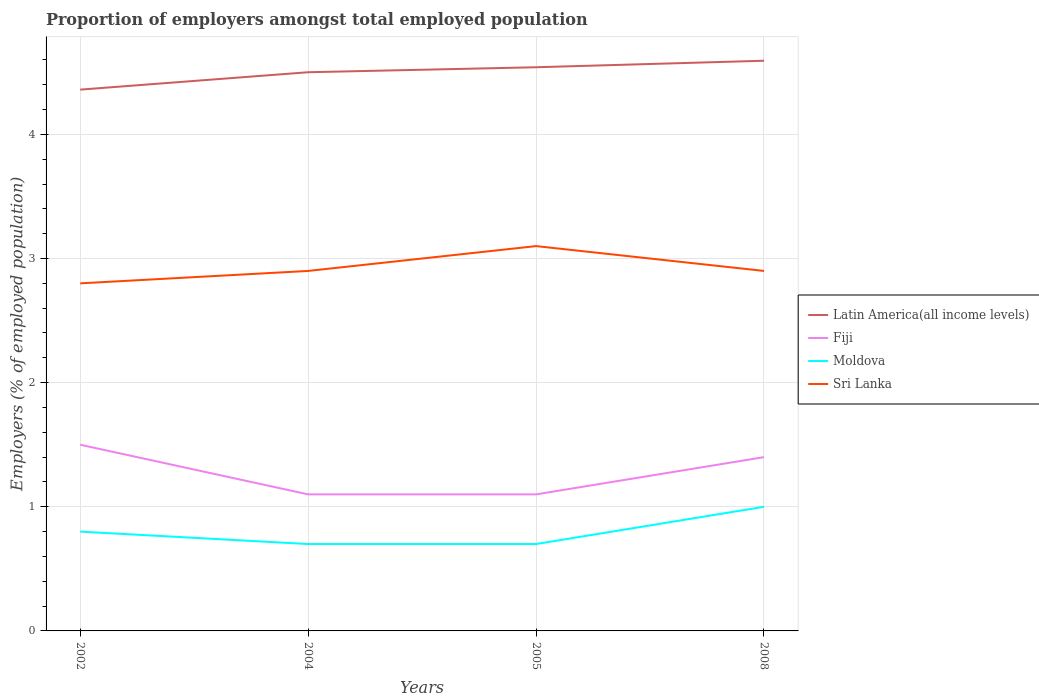How many different coloured lines are there?
Offer a very short reply. 4. Is the number of lines equal to the number of legend labels?
Provide a succinct answer. Yes. Across all years, what is the maximum proportion of employers in Latin America(all income levels)?
Make the answer very short. 4.36. In which year was the proportion of employers in Moldova maximum?
Your answer should be very brief. 2004. What is the total proportion of employers in Sri Lanka in the graph?
Offer a terse response. -0.1. What is the difference between the highest and the second highest proportion of employers in Fiji?
Provide a short and direct response. 0.4. Is the proportion of employers in Fiji strictly greater than the proportion of employers in Sri Lanka over the years?
Provide a short and direct response. Yes. How many lines are there?
Provide a succinct answer. 4. Does the graph contain grids?
Provide a succinct answer. Yes. How are the legend labels stacked?
Your answer should be compact. Vertical. What is the title of the graph?
Your answer should be very brief. Proportion of employers amongst total employed population. What is the label or title of the X-axis?
Your response must be concise. Years. What is the label or title of the Y-axis?
Provide a short and direct response. Employers (% of employed population). What is the Employers (% of employed population) in Latin America(all income levels) in 2002?
Provide a short and direct response. 4.36. What is the Employers (% of employed population) in Moldova in 2002?
Provide a short and direct response. 0.8. What is the Employers (% of employed population) in Sri Lanka in 2002?
Provide a succinct answer. 2.8. What is the Employers (% of employed population) in Latin America(all income levels) in 2004?
Keep it short and to the point. 4.5. What is the Employers (% of employed population) in Fiji in 2004?
Provide a short and direct response. 1.1. What is the Employers (% of employed population) of Moldova in 2004?
Keep it short and to the point. 0.7. What is the Employers (% of employed population) in Sri Lanka in 2004?
Provide a short and direct response. 2.9. What is the Employers (% of employed population) of Latin America(all income levels) in 2005?
Offer a terse response. 4.54. What is the Employers (% of employed population) in Fiji in 2005?
Provide a short and direct response. 1.1. What is the Employers (% of employed population) of Moldova in 2005?
Keep it short and to the point. 0.7. What is the Employers (% of employed population) in Sri Lanka in 2005?
Offer a very short reply. 3.1. What is the Employers (% of employed population) of Latin America(all income levels) in 2008?
Offer a terse response. 4.59. What is the Employers (% of employed population) in Fiji in 2008?
Offer a terse response. 1.4. What is the Employers (% of employed population) of Sri Lanka in 2008?
Give a very brief answer. 2.9. Across all years, what is the maximum Employers (% of employed population) in Latin America(all income levels)?
Keep it short and to the point. 4.59. Across all years, what is the maximum Employers (% of employed population) in Fiji?
Offer a terse response. 1.5. Across all years, what is the maximum Employers (% of employed population) in Moldova?
Give a very brief answer. 1. Across all years, what is the maximum Employers (% of employed population) in Sri Lanka?
Your response must be concise. 3.1. Across all years, what is the minimum Employers (% of employed population) of Latin America(all income levels)?
Provide a short and direct response. 4.36. Across all years, what is the minimum Employers (% of employed population) in Fiji?
Ensure brevity in your answer.  1.1. Across all years, what is the minimum Employers (% of employed population) in Moldova?
Keep it short and to the point. 0.7. Across all years, what is the minimum Employers (% of employed population) in Sri Lanka?
Your answer should be very brief. 2.8. What is the total Employers (% of employed population) of Latin America(all income levels) in the graph?
Offer a very short reply. 18. What is the total Employers (% of employed population) in Moldova in the graph?
Provide a short and direct response. 3.2. What is the total Employers (% of employed population) in Sri Lanka in the graph?
Offer a very short reply. 11.7. What is the difference between the Employers (% of employed population) in Latin America(all income levels) in 2002 and that in 2004?
Your answer should be very brief. -0.14. What is the difference between the Employers (% of employed population) of Fiji in 2002 and that in 2004?
Your answer should be very brief. 0.4. What is the difference between the Employers (% of employed population) in Sri Lanka in 2002 and that in 2004?
Provide a short and direct response. -0.1. What is the difference between the Employers (% of employed population) in Latin America(all income levels) in 2002 and that in 2005?
Keep it short and to the point. -0.18. What is the difference between the Employers (% of employed population) of Fiji in 2002 and that in 2005?
Offer a terse response. 0.4. What is the difference between the Employers (% of employed population) of Sri Lanka in 2002 and that in 2005?
Provide a succinct answer. -0.3. What is the difference between the Employers (% of employed population) of Latin America(all income levels) in 2002 and that in 2008?
Ensure brevity in your answer.  -0.23. What is the difference between the Employers (% of employed population) of Fiji in 2002 and that in 2008?
Your answer should be very brief. 0.1. What is the difference between the Employers (% of employed population) of Moldova in 2002 and that in 2008?
Give a very brief answer. -0.2. What is the difference between the Employers (% of employed population) in Sri Lanka in 2002 and that in 2008?
Make the answer very short. -0.1. What is the difference between the Employers (% of employed population) in Latin America(all income levels) in 2004 and that in 2005?
Offer a terse response. -0.04. What is the difference between the Employers (% of employed population) of Moldova in 2004 and that in 2005?
Ensure brevity in your answer.  0. What is the difference between the Employers (% of employed population) in Latin America(all income levels) in 2004 and that in 2008?
Keep it short and to the point. -0.09. What is the difference between the Employers (% of employed population) of Moldova in 2004 and that in 2008?
Offer a very short reply. -0.3. What is the difference between the Employers (% of employed population) in Latin America(all income levels) in 2005 and that in 2008?
Your response must be concise. -0.05. What is the difference between the Employers (% of employed population) in Fiji in 2005 and that in 2008?
Keep it short and to the point. -0.3. What is the difference between the Employers (% of employed population) in Latin America(all income levels) in 2002 and the Employers (% of employed population) in Fiji in 2004?
Provide a succinct answer. 3.26. What is the difference between the Employers (% of employed population) of Latin America(all income levels) in 2002 and the Employers (% of employed population) of Moldova in 2004?
Provide a short and direct response. 3.66. What is the difference between the Employers (% of employed population) of Latin America(all income levels) in 2002 and the Employers (% of employed population) of Sri Lanka in 2004?
Offer a terse response. 1.46. What is the difference between the Employers (% of employed population) of Fiji in 2002 and the Employers (% of employed population) of Moldova in 2004?
Provide a succinct answer. 0.8. What is the difference between the Employers (% of employed population) in Fiji in 2002 and the Employers (% of employed population) in Sri Lanka in 2004?
Keep it short and to the point. -1.4. What is the difference between the Employers (% of employed population) in Moldova in 2002 and the Employers (% of employed population) in Sri Lanka in 2004?
Ensure brevity in your answer.  -2.1. What is the difference between the Employers (% of employed population) of Latin America(all income levels) in 2002 and the Employers (% of employed population) of Fiji in 2005?
Ensure brevity in your answer.  3.26. What is the difference between the Employers (% of employed population) in Latin America(all income levels) in 2002 and the Employers (% of employed population) in Moldova in 2005?
Your answer should be compact. 3.66. What is the difference between the Employers (% of employed population) in Latin America(all income levels) in 2002 and the Employers (% of employed population) in Sri Lanka in 2005?
Give a very brief answer. 1.26. What is the difference between the Employers (% of employed population) of Fiji in 2002 and the Employers (% of employed population) of Moldova in 2005?
Make the answer very short. 0.8. What is the difference between the Employers (% of employed population) of Fiji in 2002 and the Employers (% of employed population) of Sri Lanka in 2005?
Provide a succinct answer. -1.6. What is the difference between the Employers (% of employed population) in Moldova in 2002 and the Employers (% of employed population) in Sri Lanka in 2005?
Give a very brief answer. -2.3. What is the difference between the Employers (% of employed population) in Latin America(all income levels) in 2002 and the Employers (% of employed population) in Fiji in 2008?
Offer a terse response. 2.96. What is the difference between the Employers (% of employed population) of Latin America(all income levels) in 2002 and the Employers (% of employed population) of Moldova in 2008?
Make the answer very short. 3.36. What is the difference between the Employers (% of employed population) of Latin America(all income levels) in 2002 and the Employers (% of employed population) of Sri Lanka in 2008?
Give a very brief answer. 1.46. What is the difference between the Employers (% of employed population) of Fiji in 2002 and the Employers (% of employed population) of Sri Lanka in 2008?
Keep it short and to the point. -1.4. What is the difference between the Employers (% of employed population) of Moldova in 2002 and the Employers (% of employed population) of Sri Lanka in 2008?
Provide a short and direct response. -2.1. What is the difference between the Employers (% of employed population) of Latin America(all income levels) in 2004 and the Employers (% of employed population) of Fiji in 2005?
Your answer should be very brief. 3.4. What is the difference between the Employers (% of employed population) in Latin America(all income levels) in 2004 and the Employers (% of employed population) in Moldova in 2005?
Your answer should be compact. 3.8. What is the difference between the Employers (% of employed population) in Latin America(all income levels) in 2004 and the Employers (% of employed population) in Sri Lanka in 2005?
Your answer should be very brief. 1.4. What is the difference between the Employers (% of employed population) in Fiji in 2004 and the Employers (% of employed population) in Sri Lanka in 2005?
Your answer should be very brief. -2. What is the difference between the Employers (% of employed population) of Latin America(all income levels) in 2004 and the Employers (% of employed population) of Fiji in 2008?
Ensure brevity in your answer.  3.1. What is the difference between the Employers (% of employed population) in Latin America(all income levels) in 2004 and the Employers (% of employed population) in Moldova in 2008?
Offer a very short reply. 3.5. What is the difference between the Employers (% of employed population) in Latin America(all income levels) in 2004 and the Employers (% of employed population) in Sri Lanka in 2008?
Ensure brevity in your answer.  1.6. What is the difference between the Employers (% of employed population) of Fiji in 2004 and the Employers (% of employed population) of Sri Lanka in 2008?
Give a very brief answer. -1.8. What is the difference between the Employers (% of employed population) of Moldova in 2004 and the Employers (% of employed population) of Sri Lanka in 2008?
Your response must be concise. -2.2. What is the difference between the Employers (% of employed population) of Latin America(all income levels) in 2005 and the Employers (% of employed population) of Fiji in 2008?
Offer a terse response. 3.14. What is the difference between the Employers (% of employed population) in Latin America(all income levels) in 2005 and the Employers (% of employed population) in Moldova in 2008?
Offer a terse response. 3.54. What is the difference between the Employers (% of employed population) of Latin America(all income levels) in 2005 and the Employers (% of employed population) of Sri Lanka in 2008?
Offer a very short reply. 1.64. What is the difference between the Employers (% of employed population) of Fiji in 2005 and the Employers (% of employed population) of Moldova in 2008?
Make the answer very short. 0.1. What is the difference between the Employers (% of employed population) in Fiji in 2005 and the Employers (% of employed population) in Sri Lanka in 2008?
Keep it short and to the point. -1.8. What is the difference between the Employers (% of employed population) in Moldova in 2005 and the Employers (% of employed population) in Sri Lanka in 2008?
Your answer should be compact. -2.2. What is the average Employers (% of employed population) in Latin America(all income levels) per year?
Keep it short and to the point. 4.5. What is the average Employers (% of employed population) in Fiji per year?
Make the answer very short. 1.27. What is the average Employers (% of employed population) of Sri Lanka per year?
Provide a short and direct response. 2.92. In the year 2002, what is the difference between the Employers (% of employed population) in Latin America(all income levels) and Employers (% of employed population) in Fiji?
Your response must be concise. 2.86. In the year 2002, what is the difference between the Employers (% of employed population) of Latin America(all income levels) and Employers (% of employed population) of Moldova?
Keep it short and to the point. 3.56. In the year 2002, what is the difference between the Employers (% of employed population) in Latin America(all income levels) and Employers (% of employed population) in Sri Lanka?
Offer a terse response. 1.56. In the year 2002, what is the difference between the Employers (% of employed population) of Fiji and Employers (% of employed population) of Moldova?
Provide a short and direct response. 0.7. In the year 2002, what is the difference between the Employers (% of employed population) in Fiji and Employers (% of employed population) in Sri Lanka?
Provide a short and direct response. -1.3. In the year 2002, what is the difference between the Employers (% of employed population) of Moldova and Employers (% of employed population) of Sri Lanka?
Keep it short and to the point. -2. In the year 2004, what is the difference between the Employers (% of employed population) in Latin America(all income levels) and Employers (% of employed population) in Fiji?
Your answer should be compact. 3.4. In the year 2004, what is the difference between the Employers (% of employed population) in Latin America(all income levels) and Employers (% of employed population) in Moldova?
Ensure brevity in your answer.  3.8. In the year 2004, what is the difference between the Employers (% of employed population) in Latin America(all income levels) and Employers (% of employed population) in Sri Lanka?
Make the answer very short. 1.6. In the year 2004, what is the difference between the Employers (% of employed population) in Fiji and Employers (% of employed population) in Moldova?
Your response must be concise. 0.4. In the year 2004, what is the difference between the Employers (% of employed population) of Moldova and Employers (% of employed population) of Sri Lanka?
Provide a short and direct response. -2.2. In the year 2005, what is the difference between the Employers (% of employed population) of Latin America(all income levels) and Employers (% of employed population) of Fiji?
Keep it short and to the point. 3.44. In the year 2005, what is the difference between the Employers (% of employed population) of Latin America(all income levels) and Employers (% of employed population) of Moldova?
Your answer should be compact. 3.84. In the year 2005, what is the difference between the Employers (% of employed population) of Latin America(all income levels) and Employers (% of employed population) of Sri Lanka?
Your answer should be very brief. 1.44. In the year 2005, what is the difference between the Employers (% of employed population) of Fiji and Employers (% of employed population) of Moldova?
Keep it short and to the point. 0.4. In the year 2005, what is the difference between the Employers (% of employed population) in Fiji and Employers (% of employed population) in Sri Lanka?
Make the answer very short. -2. In the year 2005, what is the difference between the Employers (% of employed population) of Moldova and Employers (% of employed population) of Sri Lanka?
Ensure brevity in your answer.  -2.4. In the year 2008, what is the difference between the Employers (% of employed population) of Latin America(all income levels) and Employers (% of employed population) of Fiji?
Offer a terse response. 3.19. In the year 2008, what is the difference between the Employers (% of employed population) in Latin America(all income levels) and Employers (% of employed population) in Moldova?
Your answer should be compact. 3.59. In the year 2008, what is the difference between the Employers (% of employed population) of Latin America(all income levels) and Employers (% of employed population) of Sri Lanka?
Your response must be concise. 1.69. In the year 2008, what is the difference between the Employers (% of employed population) of Moldova and Employers (% of employed population) of Sri Lanka?
Your answer should be compact. -1.9. What is the ratio of the Employers (% of employed population) of Latin America(all income levels) in 2002 to that in 2004?
Your answer should be compact. 0.97. What is the ratio of the Employers (% of employed population) in Fiji in 2002 to that in 2004?
Ensure brevity in your answer.  1.36. What is the ratio of the Employers (% of employed population) of Sri Lanka in 2002 to that in 2004?
Give a very brief answer. 0.97. What is the ratio of the Employers (% of employed population) in Latin America(all income levels) in 2002 to that in 2005?
Offer a terse response. 0.96. What is the ratio of the Employers (% of employed population) of Fiji in 2002 to that in 2005?
Make the answer very short. 1.36. What is the ratio of the Employers (% of employed population) in Moldova in 2002 to that in 2005?
Offer a very short reply. 1.14. What is the ratio of the Employers (% of employed population) of Sri Lanka in 2002 to that in 2005?
Ensure brevity in your answer.  0.9. What is the ratio of the Employers (% of employed population) of Latin America(all income levels) in 2002 to that in 2008?
Offer a very short reply. 0.95. What is the ratio of the Employers (% of employed population) of Fiji in 2002 to that in 2008?
Your answer should be compact. 1.07. What is the ratio of the Employers (% of employed population) in Sri Lanka in 2002 to that in 2008?
Make the answer very short. 0.97. What is the ratio of the Employers (% of employed population) of Latin America(all income levels) in 2004 to that in 2005?
Ensure brevity in your answer.  0.99. What is the ratio of the Employers (% of employed population) in Sri Lanka in 2004 to that in 2005?
Make the answer very short. 0.94. What is the ratio of the Employers (% of employed population) in Latin America(all income levels) in 2004 to that in 2008?
Your answer should be compact. 0.98. What is the ratio of the Employers (% of employed population) in Fiji in 2004 to that in 2008?
Provide a succinct answer. 0.79. What is the ratio of the Employers (% of employed population) of Moldova in 2004 to that in 2008?
Provide a succinct answer. 0.7. What is the ratio of the Employers (% of employed population) of Sri Lanka in 2004 to that in 2008?
Offer a terse response. 1. What is the ratio of the Employers (% of employed population) in Latin America(all income levels) in 2005 to that in 2008?
Your answer should be very brief. 0.99. What is the ratio of the Employers (% of employed population) of Fiji in 2005 to that in 2008?
Make the answer very short. 0.79. What is the ratio of the Employers (% of employed population) of Moldova in 2005 to that in 2008?
Provide a short and direct response. 0.7. What is the ratio of the Employers (% of employed population) of Sri Lanka in 2005 to that in 2008?
Ensure brevity in your answer.  1.07. What is the difference between the highest and the second highest Employers (% of employed population) in Latin America(all income levels)?
Your answer should be compact. 0.05. What is the difference between the highest and the second highest Employers (% of employed population) in Moldova?
Give a very brief answer. 0.2. What is the difference between the highest and the lowest Employers (% of employed population) of Latin America(all income levels)?
Provide a short and direct response. 0.23. What is the difference between the highest and the lowest Employers (% of employed population) in Moldova?
Offer a terse response. 0.3. 